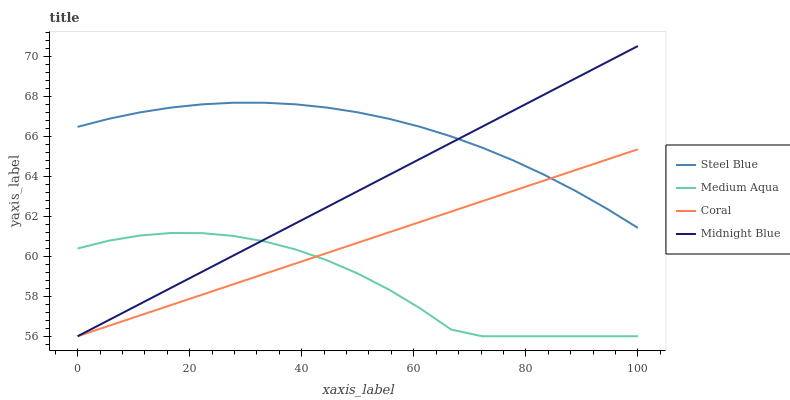Does Medium Aqua have the minimum area under the curve?
Answer yes or no. Yes. Does Steel Blue have the maximum area under the curve?
Answer yes or no. Yes. Does Steel Blue have the minimum area under the curve?
Answer yes or no. No. Does Medium Aqua have the maximum area under the curve?
Answer yes or no. No. Is Coral the smoothest?
Answer yes or no. Yes. Is Medium Aqua the roughest?
Answer yes or no. Yes. Is Steel Blue the smoothest?
Answer yes or no. No. Is Steel Blue the roughest?
Answer yes or no. No. Does Steel Blue have the lowest value?
Answer yes or no. No. Does Midnight Blue have the highest value?
Answer yes or no. Yes. Does Steel Blue have the highest value?
Answer yes or no. No. Is Medium Aqua less than Steel Blue?
Answer yes or no. Yes. Is Steel Blue greater than Medium Aqua?
Answer yes or no. Yes. Does Steel Blue intersect Midnight Blue?
Answer yes or no. Yes. Is Steel Blue less than Midnight Blue?
Answer yes or no. No. Is Steel Blue greater than Midnight Blue?
Answer yes or no. No. Does Medium Aqua intersect Steel Blue?
Answer yes or no. No. 